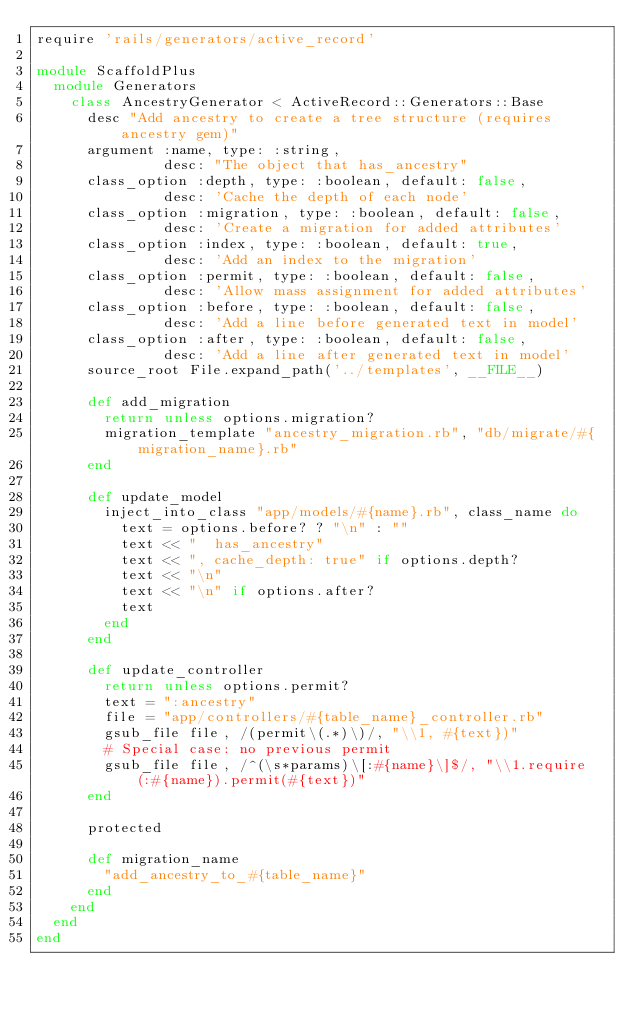Convert code to text. <code><loc_0><loc_0><loc_500><loc_500><_Ruby_>require 'rails/generators/active_record'

module ScaffoldPlus
  module Generators
    class AncestryGenerator < ActiveRecord::Generators::Base
      desc "Add ancestry to create a tree structure (requires ancestry gem)"
      argument :name, type: :string,
               desc: "The object that has_ancestry"
      class_option :depth, type: :boolean, default: false,
               desc: 'Cache the depth of each node'
      class_option :migration, type: :boolean, default: false,
               desc: 'Create a migration for added attributes'
      class_option :index, type: :boolean, default: true,
               desc: 'Add an index to the migration'
      class_option :permit, type: :boolean, default: false,
               desc: 'Allow mass assignment for added attributes'
      class_option :before, type: :boolean, default: false,
               desc: 'Add a line before generated text in model'
      class_option :after, type: :boolean, default: false,
               desc: 'Add a line after generated text in model'
      source_root File.expand_path('../templates', __FILE__)

      def add_migration
        return unless options.migration?
        migration_template "ancestry_migration.rb", "db/migrate/#{migration_name}.rb"
      end

      def update_model
        inject_into_class "app/models/#{name}.rb", class_name do
          text = options.before? ? "\n" : ""
          text << "  has_ancestry"
          text << ", cache_depth: true" if options.depth?
          text << "\n"
          text << "\n" if options.after?
          text
        end
      end

      def update_controller
        return unless options.permit?
        text = ":ancestry"
        file = "app/controllers/#{table_name}_controller.rb"
        gsub_file file, /(permit\(.*)\)/, "\\1, #{text})"
        # Special case: no previous permit
        gsub_file file, /^(\s*params)\[:#{name}\]$/, "\\1.require(:#{name}).permit(#{text})"
      end

      protected

      def migration_name
        "add_ancestry_to_#{table_name}"
      end
    end
  end
end
</code> 